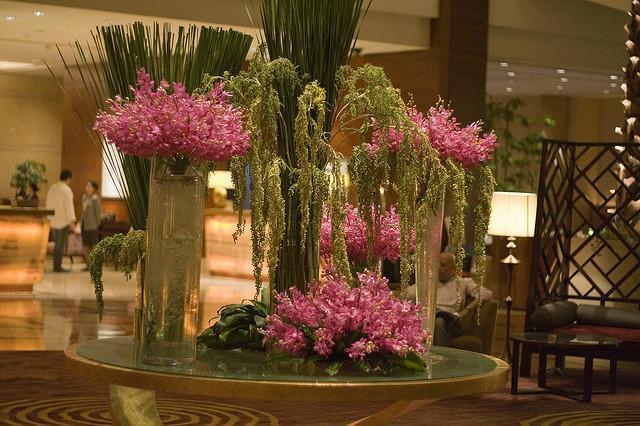How many vases are in the picture?
Give a very brief answer. 3. How many giraffes are there in the picture?
Give a very brief answer. 0. 